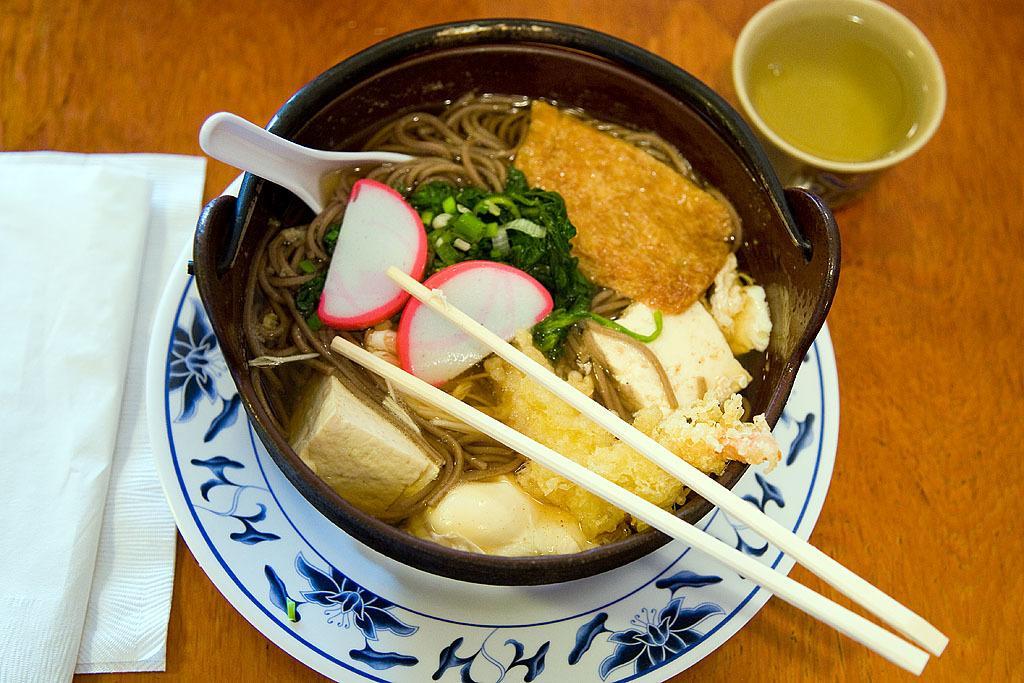Please provide a concise description of this image. The food is highlighted in this picture. The food is presented in a bowl with chopsticks and spoon. Under this bowl there is a plate. On this table there is a cup and tissue papers. 